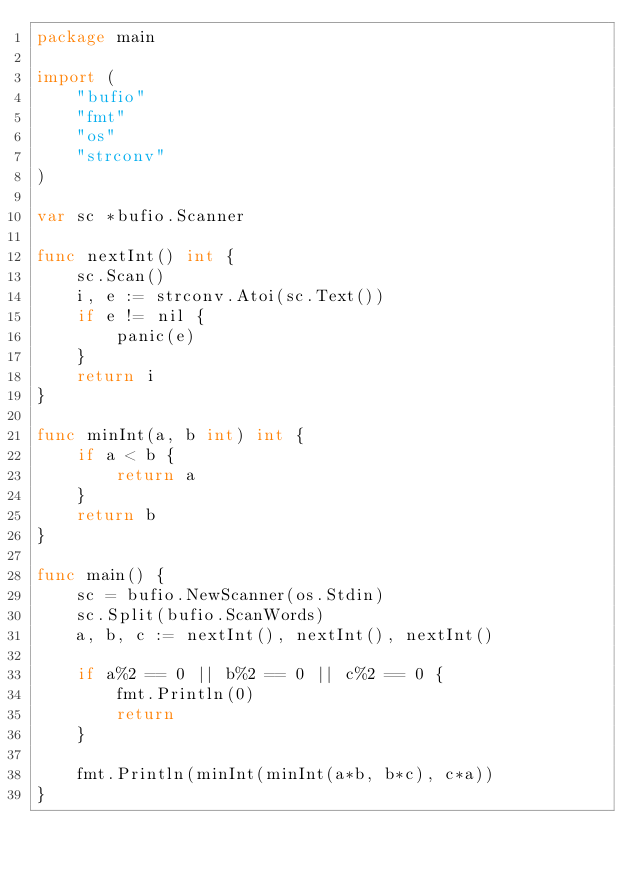Convert code to text. <code><loc_0><loc_0><loc_500><loc_500><_Go_>package main

import (
	"bufio"
	"fmt"
	"os"
	"strconv"
)

var sc *bufio.Scanner

func nextInt() int {
	sc.Scan()
	i, e := strconv.Atoi(sc.Text())
	if e != nil {
		panic(e)
	}
	return i
}

func minInt(a, b int) int {
	if a < b {
		return a
	}
	return b
}

func main() {
	sc = bufio.NewScanner(os.Stdin)
	sc.Split(bufio.ScanWords)
	a, b, c := nextInt(), nextInt(), nextInt()

	if a%2 == 0 || b%2 == 0 || c%2 == 0 {
		fmt.Println(0)
		return
	}

	fmt.Println(minInt(minInt(a*b, b*c), c*a))
}
</code> 